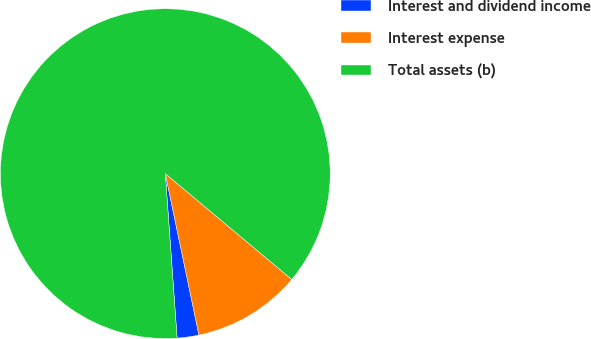Convert chart to OTSL. <chart><loc_0><loc_0><loc_500><loc_500><pie_chart><fcel>Interest and dividend income<fcel>Interest expense<fcel>Total assets (b)<nl><fcel>2.13%<fcel>10.64%<fcel>87.23%<nl></chart> 